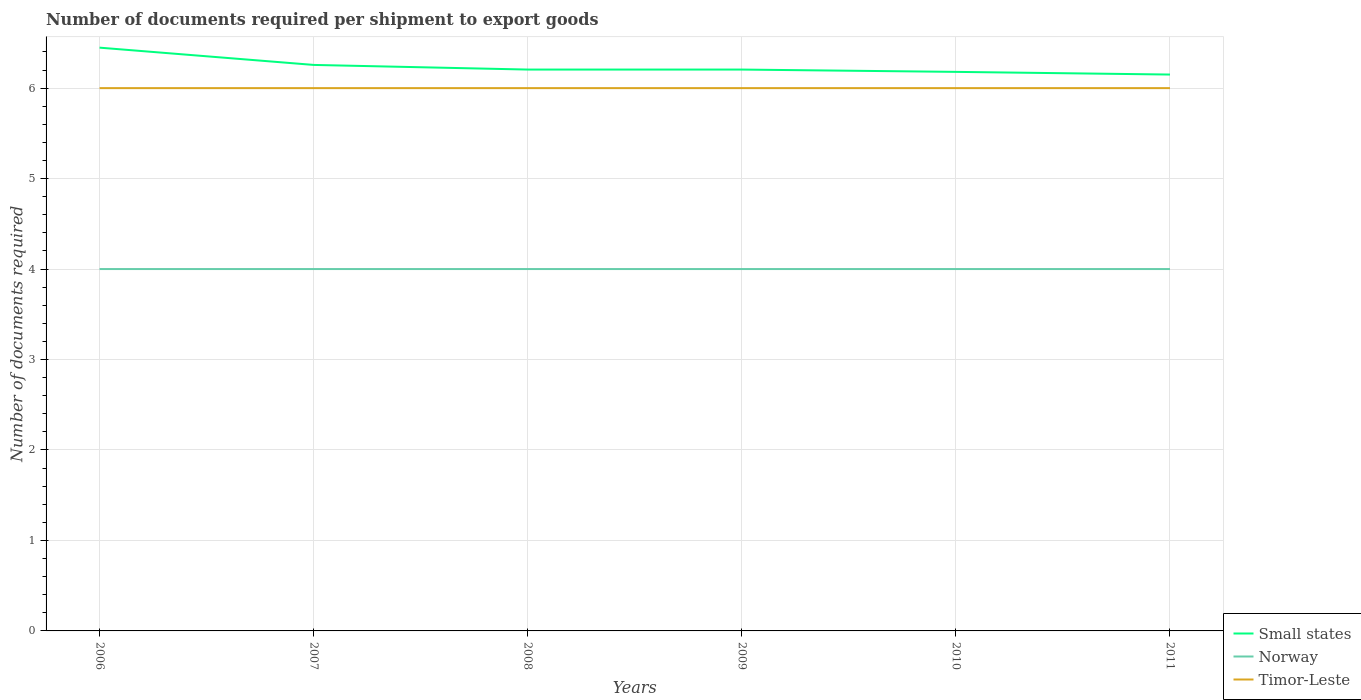How many different coloured lines are there?
Provide a succinct answer. 3. Does the line corresponding to Small states intersect with the line corresponding to Timor-Leste?
Offer a very short reply. No. Across all years, what is the maximum number of documents required per shipment to export goods in Norway?
Keep it short and to the point. 4. What is the total number of documents required per shipment to export goods in Small states in the graph?
Provide a short and direct response. 0.06. What is the difference between the highest and the lowest number of documents required per shipment to export goods in Timor-Leste?
Your response must be concise. 0. How many lines are there?
Your answer should be very brief. 3. How many years are there in the graph?
Give a very brief answer. 6. What is the difference between two consecutive major ticks on the Y-axis?
Your answer should be very brief. 1. Does the graph contain any zero values?
Your answer should be compact. No. Where does the legend appear in the graph?
Your answer should be compact. Bottom right. What is the title of the graph?
Provide a succinct answer. Number of documents required per shipment to export goods. What is the label or title of the Y-axis?
Ensure brevity in your answer.  Number of documents required. What is the Number of documents required in Small states in 2006?
Offer a very short reply. 6.45. What is the Number of documents required of Timor-Leste in 2006?
Your answer should be compact. 6. What is the Number of documents required in Small states in 2007?
Provide a short and direct response. 6.26. What is the Number of documents required in Norway in 2007?
Your response must be concise. 4. What is the Number of documents required of Timor-Leste in 2007?
Provide a short and direct response. 6. What is the Number of documents required of Small states in 2008?
Provide a short and direct response. 6.21. What is the Number of documents required of Timor-Leste in 2008?
Your answer should be compact. 6. What is the Number of documents required of Small states in 2009?
Your answer should be compact. 6.21. What is the Number of documents required of Norway in 2009?
Give a very brief answer. 4. What is the Number of documents required in Timor-Leste in 2009?
Give a very brief answer. 6. What is the Number of documents required of Small states in 2010?
Your answer should be very brief. 6.18. What is the Number of documents required of Norway in 2010?
Ensure brevity in your answer.  4. What is the Number of documents required of Timor-Leste in 2010?
Offer a terse response. 6. What is the Number of documents required of Small states in 2011?
Provide a succinct answer. 6.15. Across all years, what is the maximum Number of documents required of Small states?
Your answer should be very brief. 6.45. Across all years, what is the minimum Number of documents required in Small states?
Ensure brevity in your answer.  6.15. Across all years, what is the minimum Number of documents required of Norway?
Offer a terse response. 4. Across all years, what is the minimum Number of documents required in Timor-Leste?
Offer a very short reply. 6. What is the total Number of documents required of Small states in the graph?
Keep it short and to the point. 37.44. What is the total Number of documents required in Timor-Leste in the graph?
Offer a terse response. 36. What is the difference between the Number of documents required in Small states in 2006 and that in 2007?
Make the answer very short. 0.19. What is the difference between the Number of documents required in Norway in 2006 and that in 2007?
Give a very brief answer. 0. What is the difference between the Number of documents required of Timor-Leste in 2006 and that in 2007?
Provide a short and direct response. 0. What is the difference between the Number of documents required of Small states in 2006 and that in 2008?
Ensure brevity in your answer.  0.24. What is the difference between the Number of documents required in Norway in 2006 and that in 2008?
Your answer should be compact. 0. What is the difference between the Number of documents required in Timor-Leste in 2006 and that in 2008?
Keep it short and to the point. 0. What is the difference between the Number of documents required of Small states in 2006 and that in 2009?
Your answer should be compact. 0.24. What is the difference between the Number of documents required in Small states in 2006 and that in 2010?
Keep it short and to the point. 0.27. What is the difference between the Number of documents required of Small states in 2006 and that in 2011?
Offer a very short reply. 0.3. What is the difference between the Number of documents required of Small states in 2007 and that in 2008?
Give a very brief answer. 0.05. What is the difference between the Number of documents required in Small states in 2007 and that in 2009?
Your answer should be compact. 0.05. What is the difference between the Number of documents required in Small states in 2007 and that in 2010?
Make the answer very short. 0.08. What is the difference between the Number of documents required of Small states in 2007 and that in 2011?
Ensure brevity in your answer.  0.11. What is the difference between the Number of documents required in Timor-Leste in 2007 and that in 2011?
Provide a succinct answer. 0. What is the difference between the Number of documents required of Small states in 2008 and that in 2009?
Your answer should be compact. 0. What is the difference between the Number of documents required in Norway in 2008 and that in 2009?
Your answer should be very brief. 0. What is the difference between the Number of documents required of Small states in 2008 and that in 2010?
Your response must be concise. 0.03. What is the difference between the Number of documents required of Timor-Leste in 2008 and that in 2010?
Your response must be concise. 0. What is the difference between the Number of documents required in Small states in 2008 and that in 2011?
Your answer should be compact. 0.06. What is the difference between the Number of documents required of Norway in 2008 and that in 2011?
Ensure brevity in your answer.  0. What is the difference between the Number of documents required of Timor-Leste in 2008 and that in 2011?
Your response must be concise. 0. What is the difference between the Number of documents required of Small states in 2009 and that in 2010?
Keep it short and to the point. 0.03. What is the difference between the Number of documents required of Norway in 2009 and that in 2010?
Make the answer very short. 0. What is the difference between the Number of documents required in Small states in 2009 and that in 2011?
Offer a very short reply. 0.06. What is the difference between the Number of documents required in Norway in 2009 and that in 2011?
Your response must be concise. 0. What is the difference between the Number of documents required in Small states in 2010 and that in 2011?
Give a very brief answer. 0.03. What is the difference between the Number of documents required in Small states in 2006 and the Number of documents required in Norway in 2007?
Give a very brief answer. 2.45. What is the difference between the Number of documents required in Small states in 2006 and the Number of documents required in Timor-Leste in 2007?
Make the answer very short. 0.45. What is the difference between the Number of documents required of Small states in 2006 and the Number of documents required of Norway in 2008?
Your answer should be very brief. 2.45. What is the difference between the Number of documents required of Small states in 2006 and the Number of documents required of Timor-Leste in 2008?
Provide a succinct answer. 0.45. What is the difference between the Number of documents required of Small states in 2006 and the Number of documents required of Norway in 2009?
Keep it short and to the point. 2.45. What is the difference between the Number of documents required of Small states in 2006 and the Number of documents required of Timor-Leste in 2009?
Your response must be concise. 0.45. What is the difference between the Number of documents required of Small states in 2006 and the Number of documents required of Norway in 2010?
Offer a terse response. 2.45. What is the difference between the Number of documents required in Small states in 2006 and the Number of documents required in Timor-Leste in 2010?
Offer a very short reply. 0.45. What is the difference between the Number of documents required in Norway in 2006 and the Number of documents required in Timor-Leste in 2010?
Give a very brief answer. -2. What is the difference between the Number of documents required in Small states in 2006 and the Number of documents required in Norway in 2011?
Your answer should be compact. 2.45. What is the difference between the Number of documents required of Small states in 2006 and the Number of documents required of Timor-Leste in 2011?
Ensure brevity in your answer.  0.45. What is the difference between the Number of documents required of Small states in 2007 and the Number of documents required of Norway in 2008?
Make the answer very short. 2.26. What is the difference between the Number of documents required in Small states in 2007 and the Number of documents required in Timor-Leste in 2008?
Give a very brief answer. 0.26. What is the difference between the Number of documents required of Small states in 2007 and the Number of documents required of Norway in 2009?
Provide a succinct answer. 2.26. What is the difference between the Number of documents required in Small states in 2007 and the Number of documents required in Timor-Leste in 2009?
Provide a succinct answer. 0.26. What is the difference between the Number of documents required of Norway in 2007 and the Number of documents required of Timor-Leste in 2009?
Provide a succinct answer. -2. What is the difference between the Number of documents required of Small states in 2007 and the Number of documents required of Norway in 2010?
Make the answer very short. 2.26. What is the difference between the Number of documents required in Small states in 2007 and the Number of documents required in Timor-Leste in 2010?
Make the answer very short. 0.26. What is the difference between the Number of documents required of Small states in 2007 and the Number of documents required of Norway in 2011?
Ensure brevity in your answer.  2.26. What is the difference between the Number of documents required of Small states in 2007 and the Number of documents required of Timor-Leste in 2011?
Offer a very short reply. 0.26. What is the difference between the Number of documents required of Small states in 2008 and the Number of documents required of Norway in 2009?
Provide a succinct answer. 2.21. What is the difference between the Number of documents required in Small states in 2008 and the Number of documents required in Timor-Leste in 2009?
Your response must be concise. 0.21. What is the difference between the Number of documents required of Norway in 2008 and the Number of documents required of Timor-Leste in 2009?
Your answer should be compact. -2. What is the difference between the Number of documents required in Small states in 2008 and the Number of documents required in Norway in 2010?
Make the answer very short. 2.21. What is the difference between the Number of documents required of Small states in 2008 and the Number of documents required of Timor-Leste in 2010?
Your answer should be compact. 0.21. What is the difference between the Number of documents required in Small states in 2008 and the Number of documents required in Norway in 2011?
Ensure brevity in your answer.  2.21. What is the difference between the Number of documents required in Small states in 2008 and the Number of documents required in Timor-Leste in 2011?
Offer a very short reply. 0.21. What is the difference between the Number of documents required in Small states in 2009 and the Number of documents required in Norway in 2010?
Offer a very short reply. 2.21. What is the difference between the Number of documents required in Small states in 2009 and the Number of documents required in Timor-Leste in 2010?
Provide a short and direct response. 0.21. What is the difference between the Number of documents required in Small states in 2009 and the Number of documents required in Norway in 2011?
Provide a succinct answer. 2.21. What is the difference between the Number of documents required of Small states in 2009 and the Number of documents required of Timor-Leste in 2011?
Give a very brief answer. 0.21. What is the difference between the Number of documents required of Small states in 2010 and the Number of documents required of Norway in 2011?
Keep it short and to the point. 2.18. What is the difference between the Number of documents required of Small states in 2010 and the Number of documents required of Timor-Leste in 2011?
Your response must be concise. 0.18. What is the difference between the Number of documents required in Norway in 2010 and the Number of documents required in Timor-Leste in 2011?
Give a very brief answer. -2. What is the average Number of documents required in Small states per year?
Provide a succinct answer. 6.24. What is the average Number of documents required in Timor-Leste per year?
Make the answer very short. 6. In the year 2006, what is the difference between the Number of documents required of Small states and Number of documents required of Norway?
Offer a very short reply. 2.45. In the year 2006, what is the difference between the Number of documents required of Small states and Number of documents required of Timor-Leste?
Your response must be concise. 0.45. In the year 2007, what is the difference between the Number of documents required in Small states and Number of documents required in Norway?
Offer a terse response. 2.26. In the year 2007, what is the difference between the Number of documents required in Small states and Number of documents required in Timor-Leste?
Give a very brief answer. 0.26. In the year 2007, what is the difference between the Number of documents required in Norway and Number of documents required in Timor-Leste?
Ensure brevity in your answer.  -2. In the year 2008, what is the difference between the Number of documents required of Small states and Number of documents required of Norway?
Keep it short and to the point. 2.21. In the year 2008, what is the difference between the Number of documents required in Small states and Number of documents required in Timor-Leste?
Offer a very short reply. 0.21. In the year 2009, what is the difference between the Number of documents required of Small states and Number of documents required of Norway?
Keep it short and to the point. 2.21. In the year 2009, what is the difference between the Number of documents required of Small states and Number of documents required of Timor-Leste?
Keep it short and to the point. 0.21. In the year 2010, what is the difference between the Number of documents required in Small states and Number of documents required in Norway?
Make the answer very short. 2.18. In the year 2010, what is the difference between the Number of documents required in Small states and Number of documents required in Timor-Leste?
Keep it short and to the point. 0.18. In the year 2011, what is the difference between the Number of documents required of Small states and Number of documents required of Norway?
Your answer should be compact. 2.15. In the year 2011, what is the difference between the Number of documents required of Small states and Number of documents required of Timor-Leste?
Your answer should be compact. 0.15. What is the ratio of the Number of documents required of Small states in 2006 to that in 2007?
Provide a succinct answer. 1.03. What is the ratio of the Number of documents required in Small states in 2006 to that in 2008?
Your answer should be compact. 1.04. What is the ratio of the Number of documents required in Norway in 2006 to that in 2008?
Provide a short and direct response. 1. What is the ratio of the Number of documents required in Timor-Leste in 2006 to that in 2008?
Provide a short and direct response. 1. What is the ratio of the Number of documents required in Small states in 2006 to that in 2009?
Keep it short and to the point. 1.04. What is the ratio of the Number of documents required of Norway in 2006 to that in 2009?
Offer a very short reply. 1. What is the ratio of the Number of documents required in Timor-Leste in 2006 to that in 2009?
Ensure brevity in your answer.  1. What is the ratio of the Number of documents required in Small states in 2006 to that in 2010?
Provide a short and direct response. 1.04. What is the ratio of the Number of documents required of Norway in 2006 to that in 2010?
Your answer should be compact. 1. What is the ratio of the Number of documents required in Timor-Leste in 2006 to that in 2010?
Make the answer very short. 1. What is the ratio of the Number of documents required in Small states in 2006 to that in 2011?
Make the answer very short. 1.05. What is the ratio of the Number of documents required of Norway in 2006 to that in 2011?
Make the answer very short. 1. What is the ratio of the Number of documents required in Timor-Leste in 2006 to that in 2011?
Make the answer very short. 1. What is the ratio of the Number of documents required of Small states in 2007 to that in 2008?
Your response must be concise. 1.01. What is the ratio of the Number of documents required in Small states in 2007 to that in 2009?
Your response must be concise. 1.01. What is the ratio of the Number of documents required in Timor-Leste in 2007 to that in 2009?
Your answer should be compact. 1. What is the ratio of the Number of documents required of Small states in 2007 to that in 2010?
Ensure brevity in your answer.  1.01. What is the ratio of the Number of documents required in Small states in 2007 to that in 2011?
Offer a terse response. 1.02. What is the ratio of the Number of documents required of Small states in 2008 to that in 2009?
Your answer should be very brief. 1. What is the ratio of the Number of documents required in Norway in 2008 to that in 2009?
Your response must be concise. 1. What is the ratio of the Number of documents required in Timor-Leste in 2008 to that in 2009?
Offer a terse response. 1. What is the ratio of the Number of documents required of Small states in 2008 to that in 2010?
Your answer should be compact. 1. What is the ratio of the Number of documents required in Norway in 2008 to that in 2010?
Keep it short and to the point. 1. What is the ratio of the Number of documents required in Timor-Leste in 2008 to that in 2010?
Your answer should be very brief. 1. What is the ratio of the Number of documents required of Norway in 2008 to that in 2011?
Provide a short and direct response. 1. What is the ratio of the Number of documents required in Norway in 2009 to that in 2011?
Provide a succinct answer. 1. What is the ratio of the Number of documents required of Small states in 2010 to that in 2011?
Provide a short and direct response. 1. What is the ratio of the Number of documents required in Norway in 2010 to that in 2011?
Your response must be concise. 1. What is the ratio of the Number of documents required in Timor-Leste in 2010 to that in 2011?
Offer a terse response. 1. What is the difference between the highest and the second highest Number of documents required of Small states?
Ensure brevity in your answer.  0.19. What is the difference between the highest and the second highest Number of documents required in Timor-Leste?
Your response must be concise. 0. What is the difference between the highest and the lowest Number of documents required of Small states?
Offer a terse response. 0.3. What is the difference between the highest and the lowest Number of documents required in Norway?
Ensure brevity in your answer.  0. 